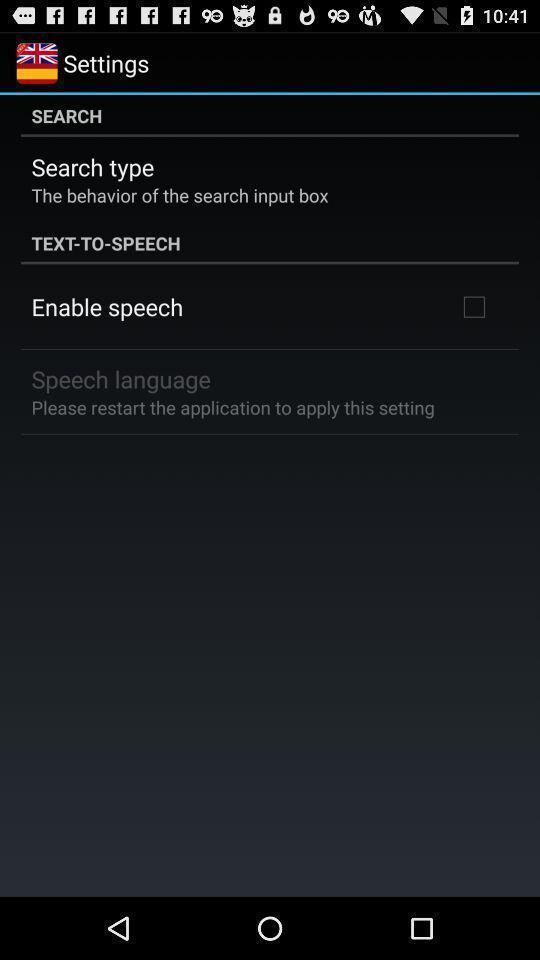What is the overall content of this screenshot? Page showing menu in settings options. 